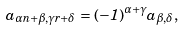Convert formula to latex. <formula><loc_0><loc_0><loc_500><loc_500>a _ { \alpha n + \beta , \gamma r + \delta } = ( - 1 ) ^ { \alpha + \gamma } a _ { \beta , \delta } ,</formula> 